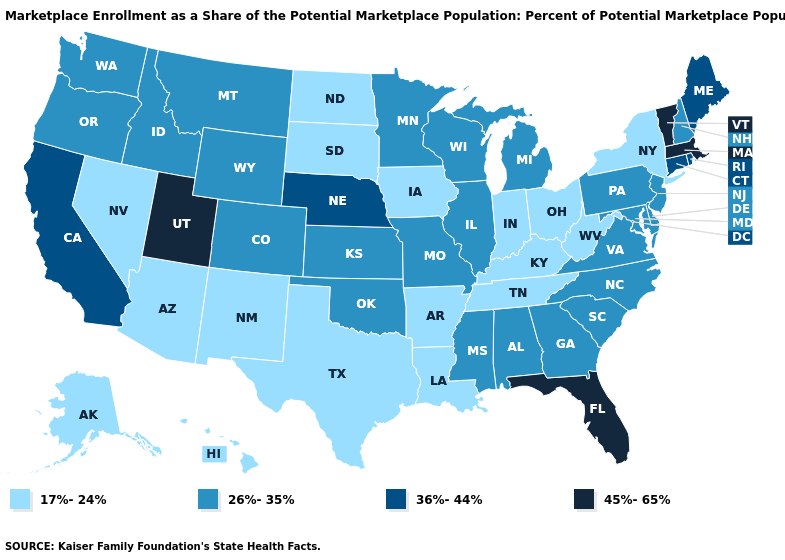Does Nebraska have the lowest value in the USA?
Quick response, please. No. What is the highest value in states that border Alabama?
Keep it brief. 45%-65%. Name the states that have a value in the range 36%-44%?
Answer briefly. California, Connecticut, Maine, Nebraska, Rhode Island. What is the highest value in the MidWest ?
Write a very short answer. 36%-44%. How many symbols are there in the legend?
Write a very short answer. 4. Among the states that border Texas , which have the highest value?
Quick response, please. Oklahoma. Does Montana have the lowest value in the USA?
Concise answer only. No. What is the lowest value in the South?
Short answer required. 17%-24%. Which states hav the highest value in the West?
Write a very short answer. Utah. Does the first symbol in the legend represent the smallest category?
Concise answer only. Yes. Does the first symbol in the legend represent the smallest category?
Answer briefly. Yes. What is the value of Louisiana?
Answer briefly. 17%-24%. Name the states that have a value in the range 17%-24%?
Give a very brief answer. Alaska, Arizona, Arkansas, Hawaii, Indiana, Iowa, Kentucky, Louisiana, Nevada, New Mexico, New York, North Dakota, Ohio, South Dakota, Tennessee, Texas, West Virginia. Which states hav the highest value in the Northeast?
Answer briefly. Massachusetts, Vermont. 